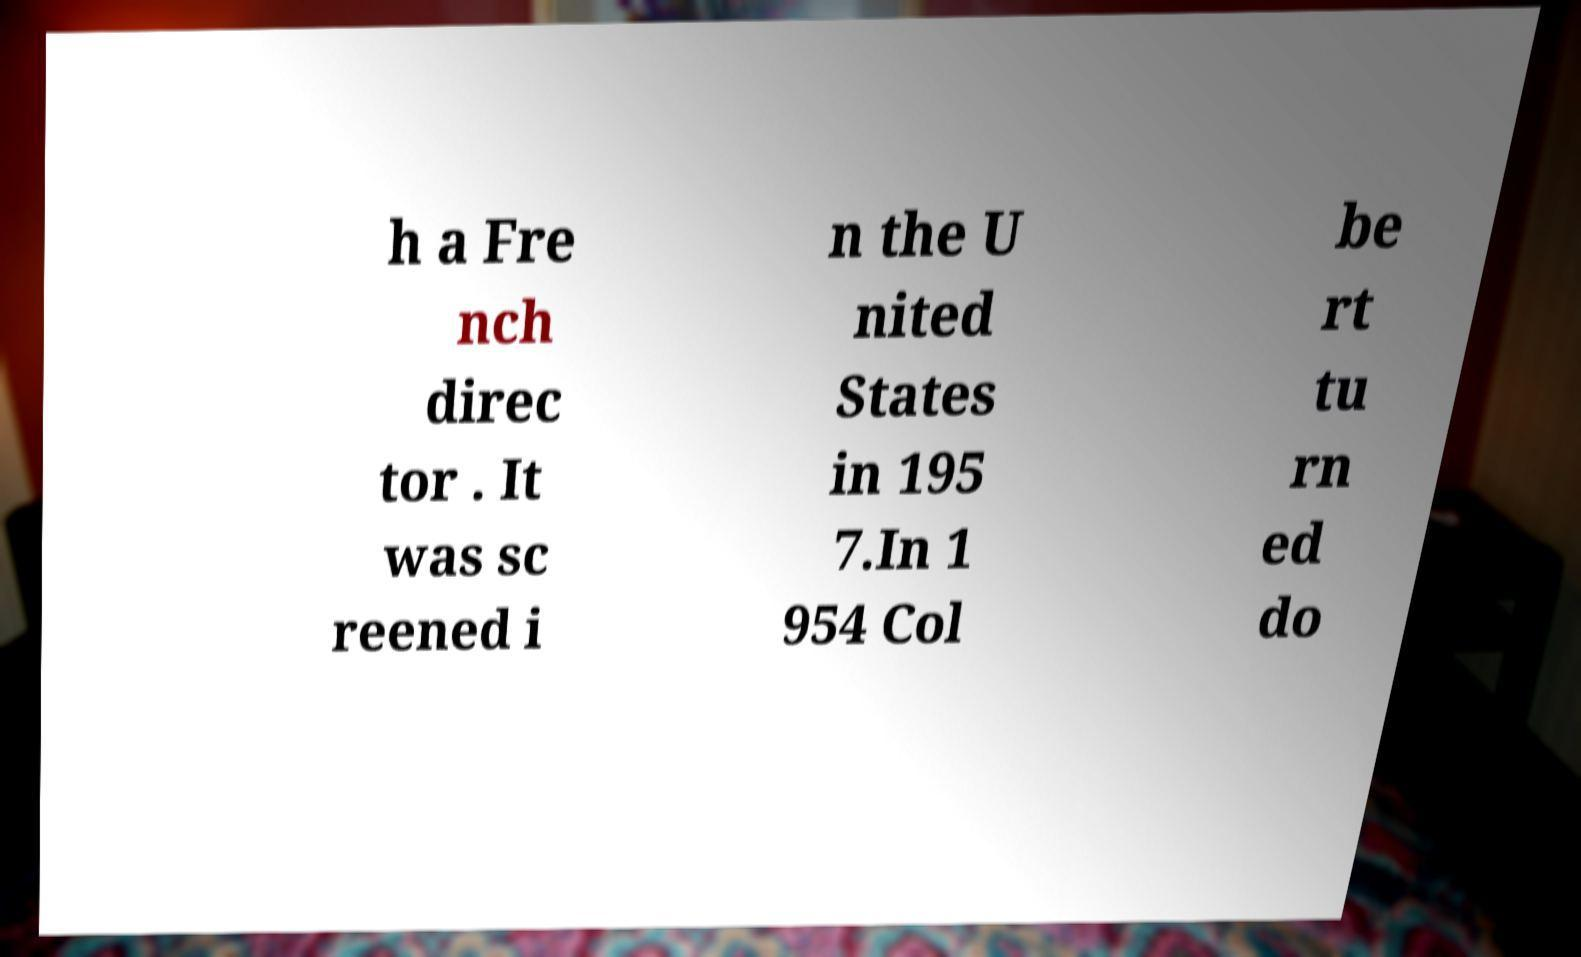There's text embedded in this image that I need extracted. Can you transcribe it verbatim? h a Fre nch direc tor . It was sc reened i n the U nited States in 195 7.In 1 954 Col be rt tu rn ed do 